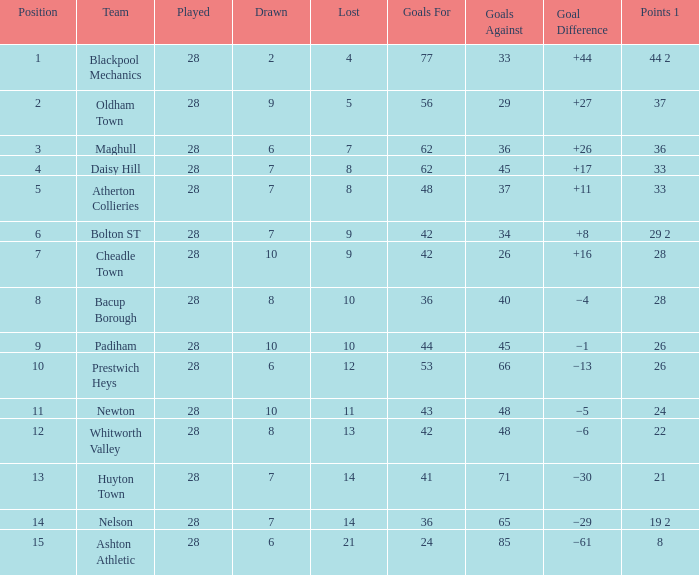For entries with lost larger than 21 and goals for smaller than 36, what is the average drawn? None. 